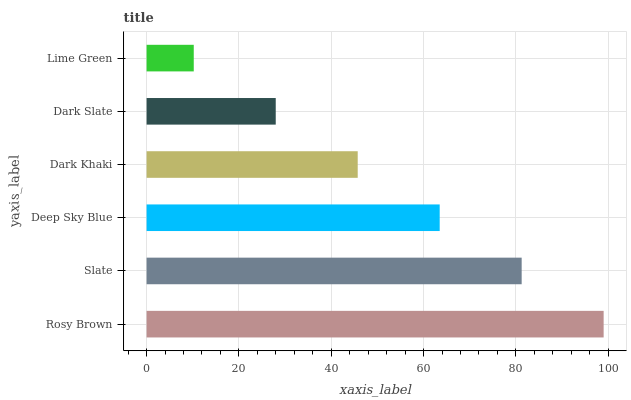Is Lime Green the minimum?
Answer yes or no. Yes. Is Rosy Brown the maximum?
Answer yes or no. Yes. Is Slate the minimum?
Answer yes or no. No. Is Slate the maximum?
Answer yes or no. No. Is Rosy Brown greater than Slate?
Answer yes or no. Yes. Is Slate less than Rosy Brown?
Answer yes or no. Yes. Is Slate greater than Rosy Brown?
Answer yes or no. No. Is Rosy Brown less than Slate?
Answer yes or no. No. Is Deep Sky Blue the high median?
Answer yes or no. Yes. Is Dark Khaki the low median?
Answer yes or no. Yes. Is Rosy Brown the high median?
Answer yes or no. No. Is Slate the low median?
Answer yes or no. No. 